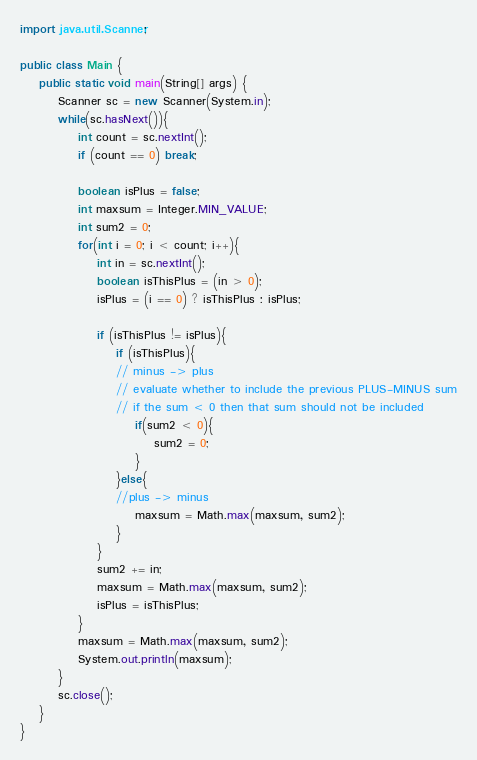<code> <loc_0><loc_0><loc_500><loc_500><_Java_>import java.util.Scanner;

public class Main {
	public static void main(String[] args) {
		Scanner sc = new Scanner(System.in);
		while(sc.hasNext()){
			int count = sc.nextInt();
			if (count == 0) break;
			
			boolean isPlus = false;
			int maxsum = Integer.MIN_VALUE;
			int sum2 = 0;
			for(int i = 0; i < count; i++){
				int in = sc.nextInt();
				boolean isThisPlus = (in > 0);
				isPlus = (i == 0) ? isThisPlus : isPlus;
				
				if (isThisPlus != isPlus){
					if (isThisPlus){
					// minus -> plus
					// evaluate whether to include the previous PLUS-MINUS sum
					// if the sum < 0 then that sum should not be included
						if(sum2 < 0){
							sum2 = 0;
						}
					}else{
					//plus -> minus
						maxsum = Math.max(maxsum, sum2);
					}
				}
				sum2 += in;
				maxsum = Math.max(maxsum, sum2);
				isPlus = isThisPlus;
			}
			maxsum = Math.max(maxsum, sum2);
			System.out.println(maxsum);
		}
		sc.close();
	}
}</code> 